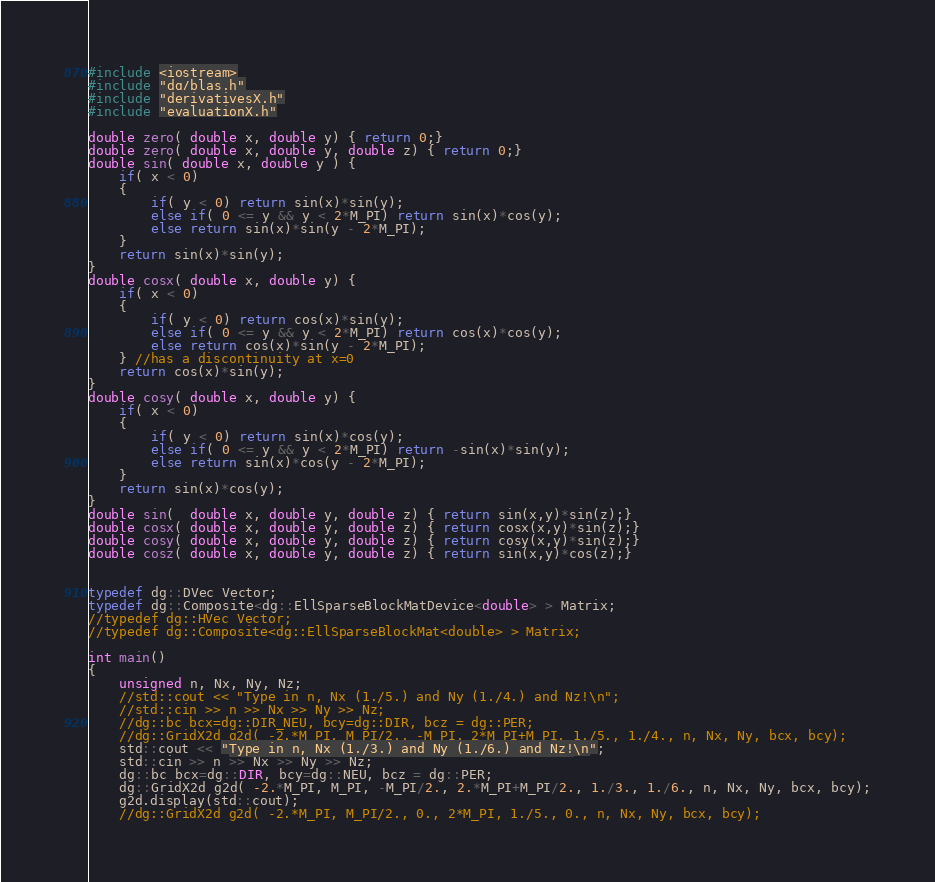Convert code to text. <code><loc_0><loc_0><loc_500><loc_500><_Cuda_>#include <iostream>
#include "dg/blas.h"
#include "derivativesX.h"
#include "evaluationX.h"

double zero( double x, double y) { return 0;}
double zero( double x, double y, double z) { return 0;}
double sin( double x, double y ) {
    if( x < 0)
    {
        if( y < 0) return sin(x)*sin(y);
        else if( 0 <= y && y < 2*M_PI) return sin(x)*cos(y);
        else return sin(x)*sin(y - 2*M_PI);
    }
    return sin(x)*sin(y);
}
double cosx( double x, double y) {
    if( x < 0)
    {
        if( y < 0) return cos(x)*sin(y);
        else if( 0 <= y && y < 2*M_PI) return cos(x)*cos(y);
        else return cos(x)*sin(y - 2*M_PI);
    } //has a discontinuity at x=0
    return cos(x)*sin(y);
}
double cosy( double x, double y) {
    if( x < 0)
    {
        if( y < 0) return sin(x)*cos(y);
        else if( 0 <= y && y < 2*M_PI) return -sin(x)*sin(y);
        else return sin(x)*cos(y - 2*M_PI);
    }
    return sin(x)*cos(y);
}
double sin(  double x, double y, double z) { return sin(x,y)*sin(z);}
double cosx( double x, double y, double z) { return cosx(x,y)*sin(z);}
double cosy( double x, double y, double z) { return cosy(x,y)*sin(z);}
double cosz( double x, double y, double z) { return sin(x,y)*cos(z);}


typedef dg::DVec Vector;
typedef dg::Composite<dg::EllSparseBlockMatDevice<double> > Matrix;
//typedef dg::HVec Vector;
//typedef dg::Composite<dg::EllSparseBlockMat<double> > Matrix;

int main()
{
    unsigned n, Nx, Ny, Nz;
    //std::cout << "Type in n, Nx (1./5.) and Ny (1./4.) and Nz!\n";
    //std::cin >> n >> Nx >> Ny >> Nz;
    //dg::bc bcx=dg::DIR_NEU, bcy=dg::DIR, bcz = dg::PER;
    //dg::GridX2d g2d( -2.*M_PI, M_PI/2., -M_PI, 2*M_PI+M_PI, 1./5., 1./4., n, Nx, Ny, bcx, bcy);
    std::cout << "Type in n, Nx (1./3.) and Ny (1./6.) and Nz!\n";
    std::cin >> n >> Nx >> Ny >> Nz;
    dg::bc bcx=dg::DIR, bcy=dg::NEU, bcz = dg::PER;
    dg::GridX2d g2d( -2.*M_PI, M_PI, -M_PI/2., 2.*M_PI+M_PI/2., 1./3., 1./6., n, Nx, Ny, bcx, bcy);
    g2d.display(std::cout);
    //dg::GridX2d g2d( -2.*M_PI, M_PI/2., 0., 2*M_PI, 1./5., 0., n, Nx, Ny, bcx, bcy);</code> 